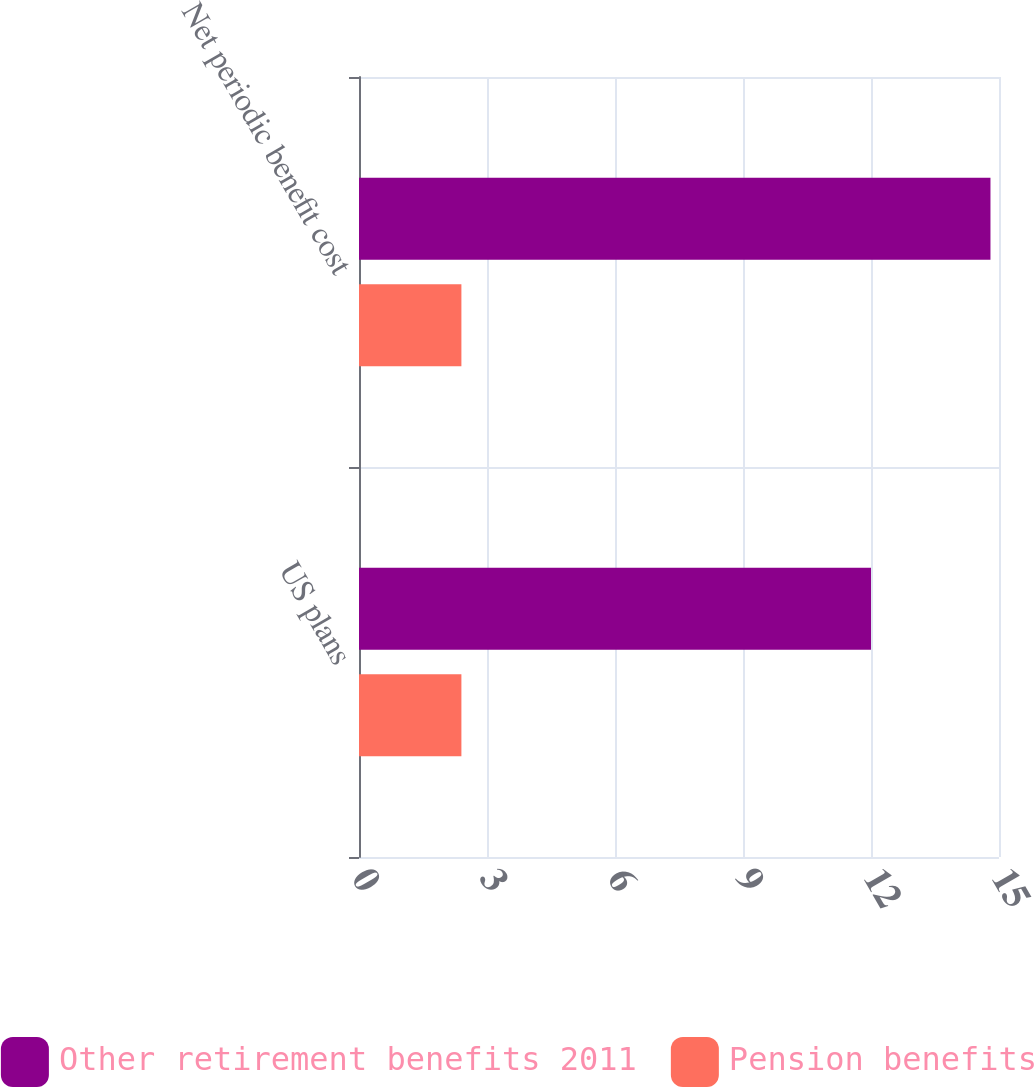Convert chart to OTSL. <chart><loc_0><loc_0><loc_500><loc_500><stacked_bar_chart><ecel><fcel>US plans<fcel>Net periodic benefit cost<nl><fcel>Other retirement benefits 2011<fcel>12<fcel>14.8<nl><fcel>Pension benefits<fcel>2.4<fcel>2.4<nl></chart> 